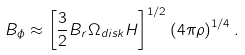Convert formula to latex. <formula><loc_0><loc_0><loc_500><loc_500>B _ { \phi } \approx \left [ \frac { 3 } { 2 } B _ { r } \Omega _ { d i s k } H \right ] ^ { 1 / 2 } \left ( 4 \pi \rho \right ) ^ { 1 / 4 } . \\</formula> 